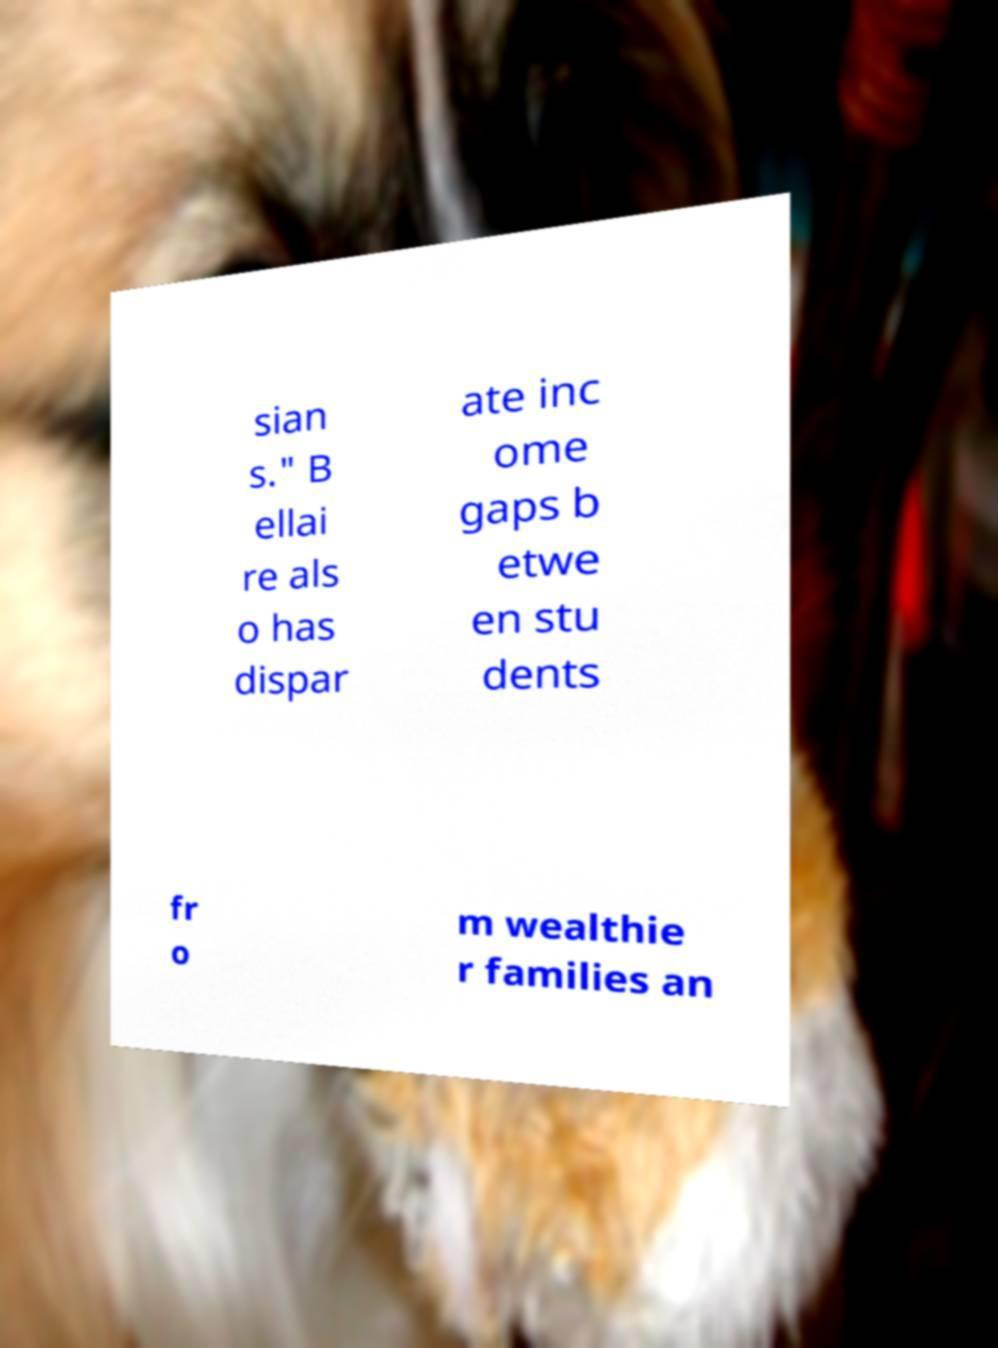For documentation purposes, I need the text within this image transcribed. Could you provide that? sian s." B ellai re als o has dispar ate inc ome gaps b etwe en stu dents fr o m wealthie r families an 